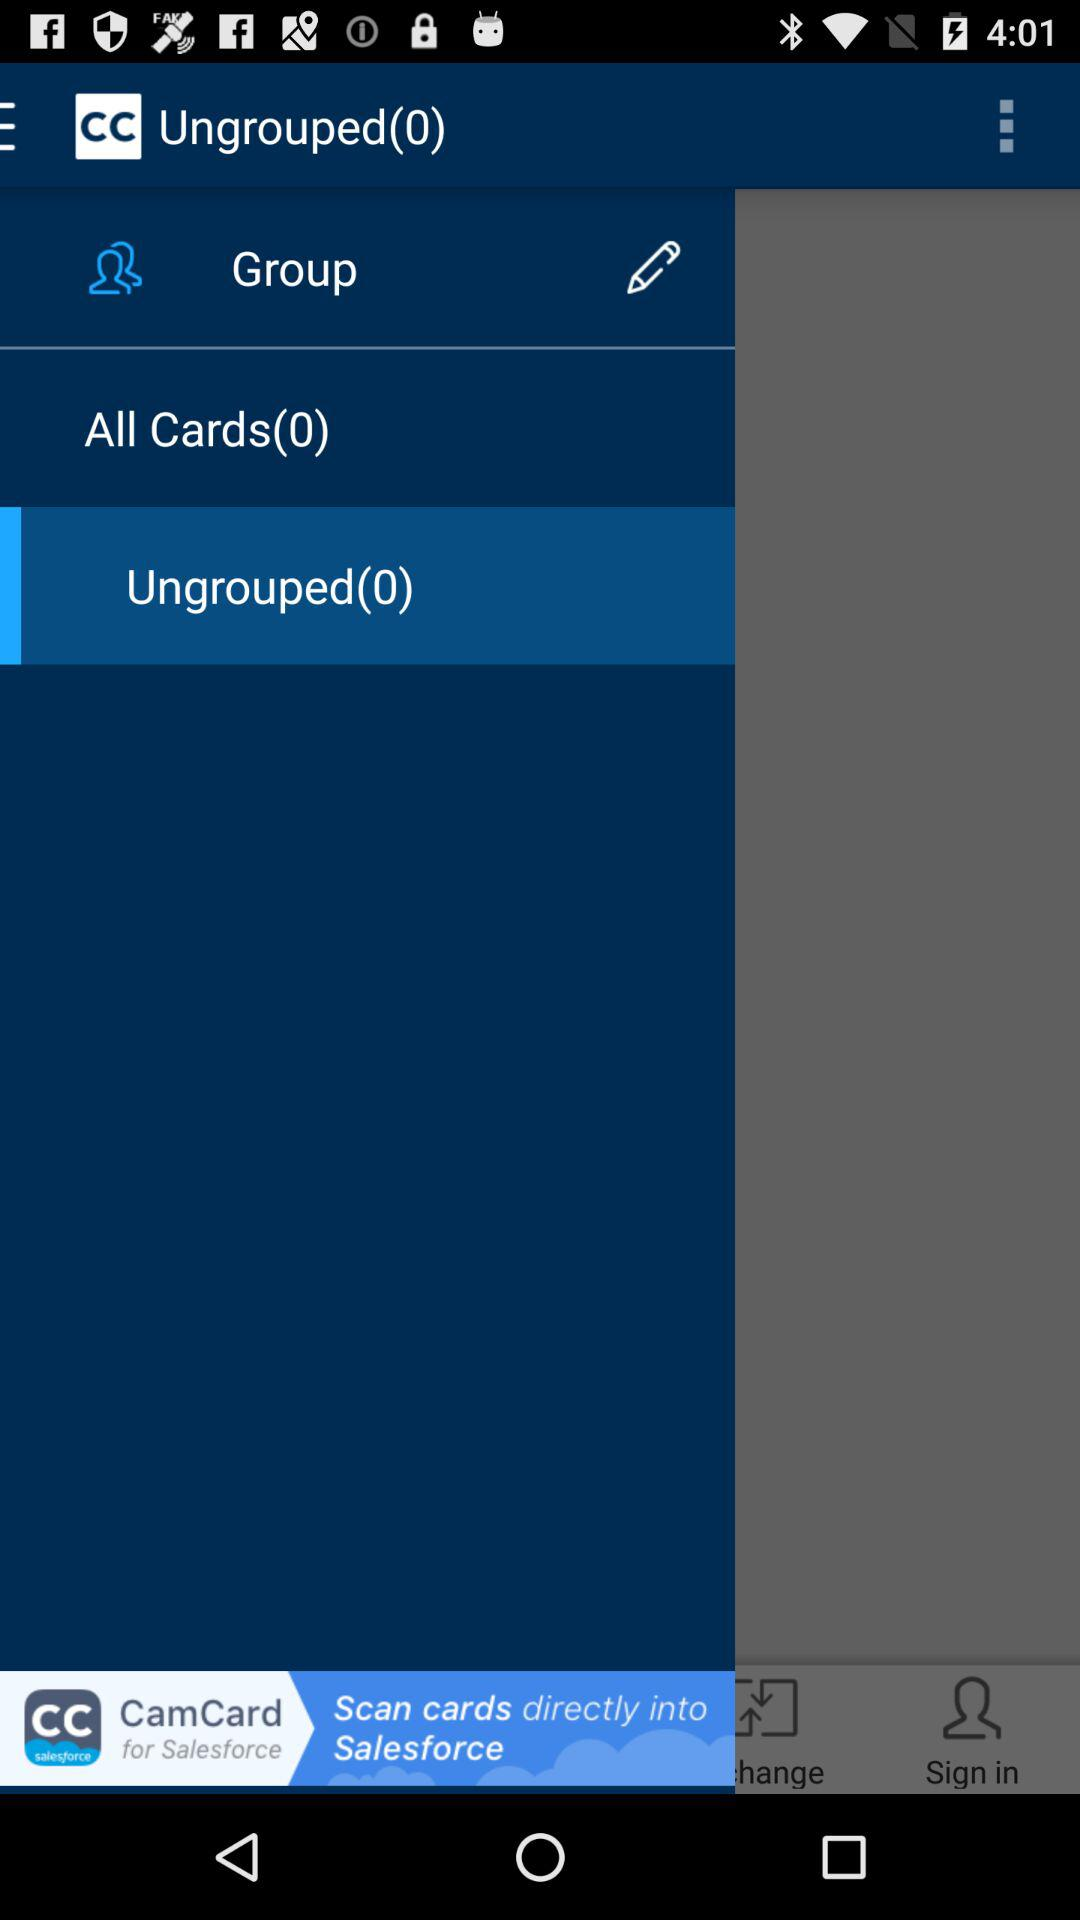How many "Ungrouped" are there? There are 0 "Ungrouped". 